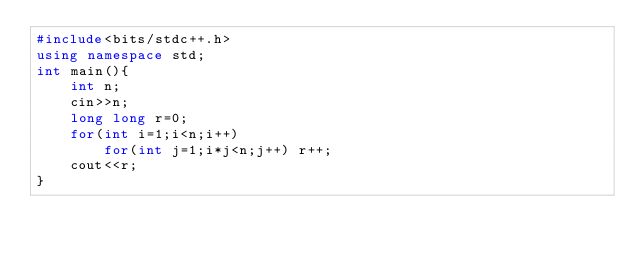<code> <loc_0><loc_0><loc_500><loc_500><_C++_>#include<bits/stdc++.h>
using namespace std;
int main(){
    int n;
    cin>>n;
    long long r=0;
    for(int i=1;i<n;i++)
        for(int j=1;i*j<n;j++) r++;
    cout<<r;
}
</code> 